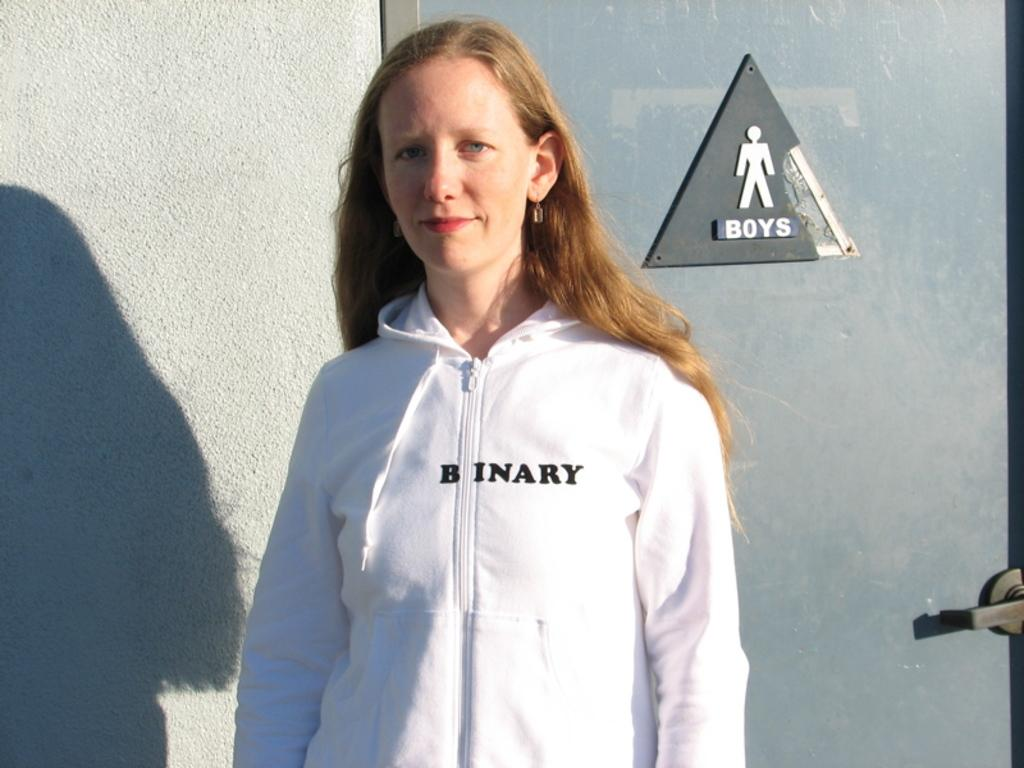<image>
Describe the image concisely. a lady with the word binary on her shirt 